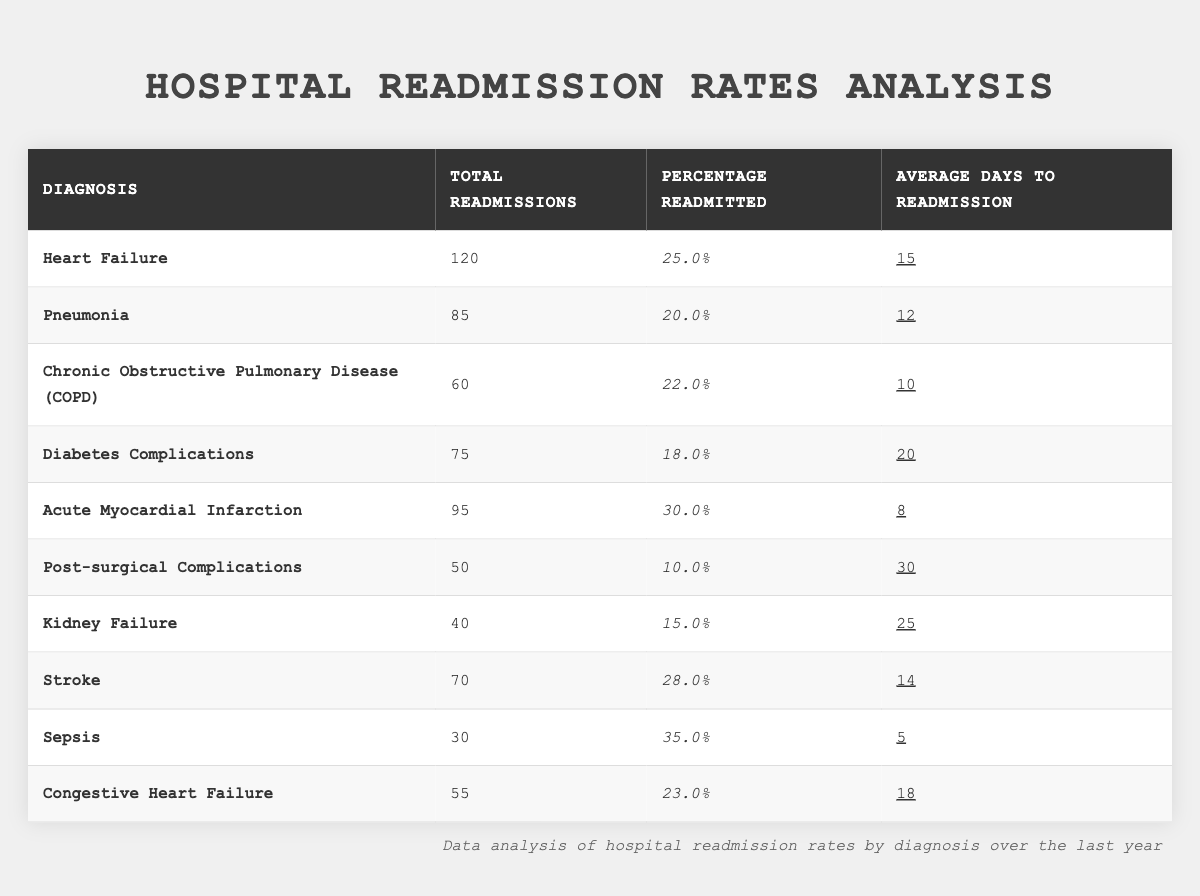What is the total number of readmissions for Diabetes Complications? Looking at the table, the total number of readmissions for Diabetes Complications is listed directly. It shows 75 readmissions.
Answer: 75 Which diagnosis has the highest percentage of readmissions? By examining the percentage readmitted column, Sepsis has the highest percentage at 35.0%.
Answer: Sepsis What is the average days to readmission for Chronic Obstructive Pulmonary Disease? The average days to readmission for Chronic Obstructive Pulmonary Disease is shown directly in the table as 10 days.
Answer: 10 days How many more readmissions does Heart Failure have compared to Kidney Failure? Heart Failure has 120 total readmissions while Kidney Failure has 40. The difference is 120 - 40 = 80 readmissions.
Answer: 80 What is the sum of the total readmissions for Acute Myocardial Infarction and Stroke? Total readmissions for Acute Myocardial Infarction is 95 and for Stroke is 70. Adding them together gives 95 + 70 = 165.
Answer: 165 Are more patients readmitted for Sepsis than for Pneumonia? Sepsis has 30 readmissions (35.0%) and Pneumonia has 85 readmissions (20.0%). Since 30 is less than 85, the answer is no.
Answer: No What is the average percentage of readmissions across all diagnoses listed? First, we sum the percentage readmitted for all diagnoses: 25.0 + 20.0 + 22.0 + 18.0 + 30.0 + 10.0 + 15.0 + 28.0 + 35.0 + 23.0 = 236. Then, divide this sum by the number of diagnoses, which is 10: 236 / 10 = 23.6%.
Answer: 23.6% Which diagnosis has the longest average days to readmission? By scanning the average days to readmission column, Post-surgical Complications has the highest at 30 days.
Answer: Post-surgical Complications What percentage of readmissions does Diabetes Complications account for compared to Heart Failure? Diabetes Complications has 75 readmissions and Heart Failure has 120 readmissions. The percentage is calculated as (75 / 120) * 100 = 62.5%.
Answer: 62.5% Is the average days to readmission for Stroke less than that for Diabetes Complications? Stroke has an average of 14 days and Diabetes Complications has 20 days. Since 14 is less than 20, the statement is true.
Answer: Yes 